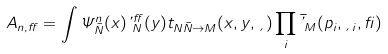Convert formula to latex. <formula><loc_0><loc_0><loc_500><loc_500>A _ { n , \alpha } = \int \Psi ^ { n } _ { \bar { N } } ( { x } ) \varphi ^ { \alpha } _ { N } ( { y } ) t _ { N \bar { N } \rightarrow M } ( { x } , { y } , { \xi } ) \prod _ { i } \bar { \varphi } _ { M } ( { p _ { i } } , { \xi _ { i } } , { \beta } )</formula> 